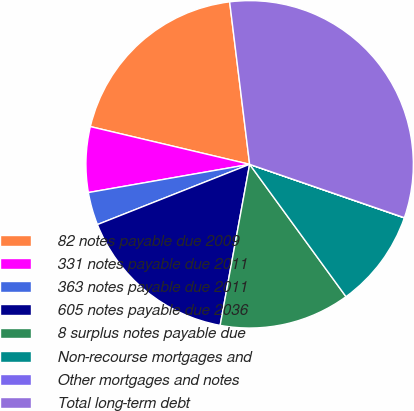<chart> <loc_0><loc_0><loc_500><loc_500><pie_chart><fcel>82 notes payable due 2009<fcel>331 notes payable due 2011<fcel>363 notes payable due 2011<fcel>605 notes payable due 2036<fcel>8 surplus notes payable due<fcel>Non-recourse mortgages and<fcel>Other mortgages and notes<fcel>Total long-term debt<nl><fcel>19.35%<fcel>6.46%<fcel>3.24%<fcel>16.12%<fcel>12.9%<fcel>9.68%<fcel>0.02%<fcel>32.23%<nl></chart> 